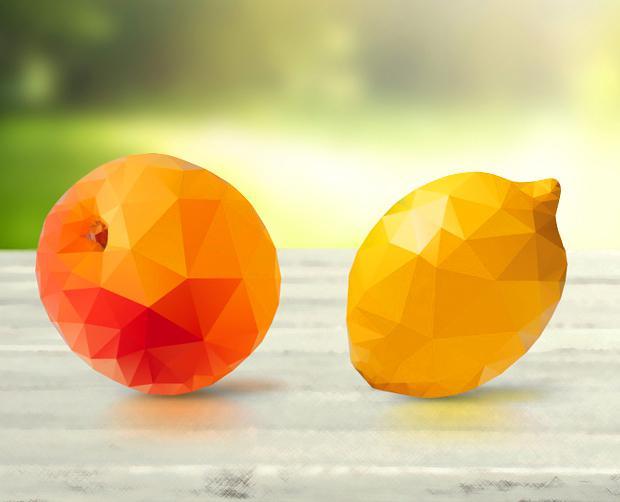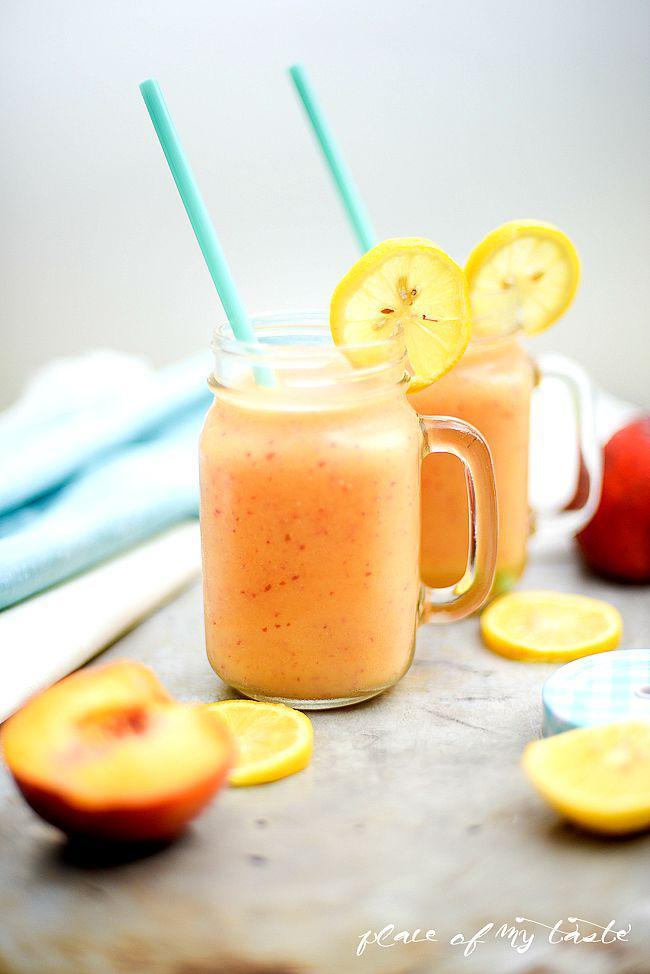The first image is the image on the left, the second image is the image on the right. Examine the images to the left and right. Is the description "The right image contains two sliced lemons hanging from the lid of two glass smoothie cups." accurate? Answer yes or no. Yes. 